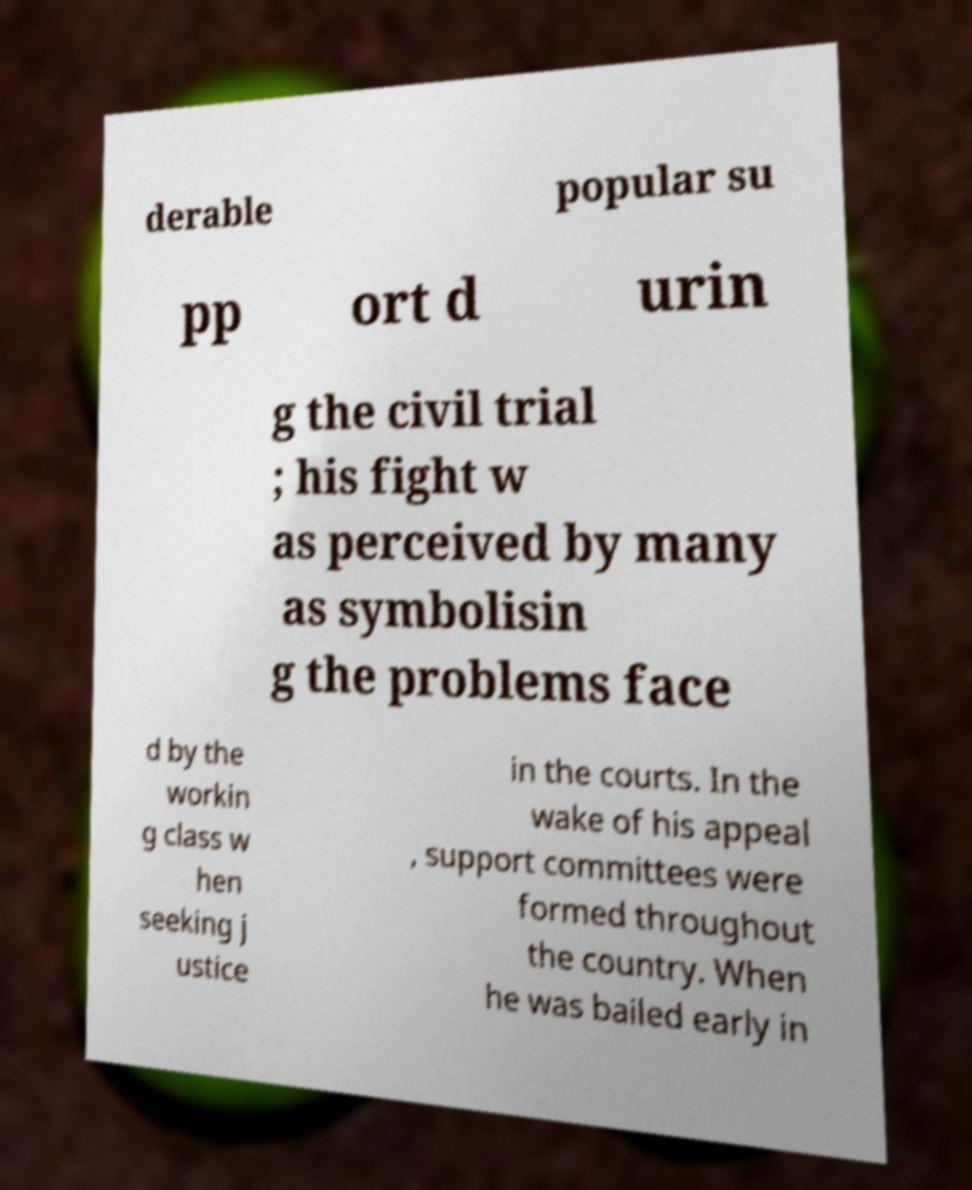Could you extract and type out the text from this image? derable popular su pp ort d urin g the civil trial ; his fight w as perceived by many as symbolisin g the problems face d by the workin g class w hen seeking j ustice in the courts. In the wake of his appeal , support committees were formed throughout the country. When he was bailed early in 